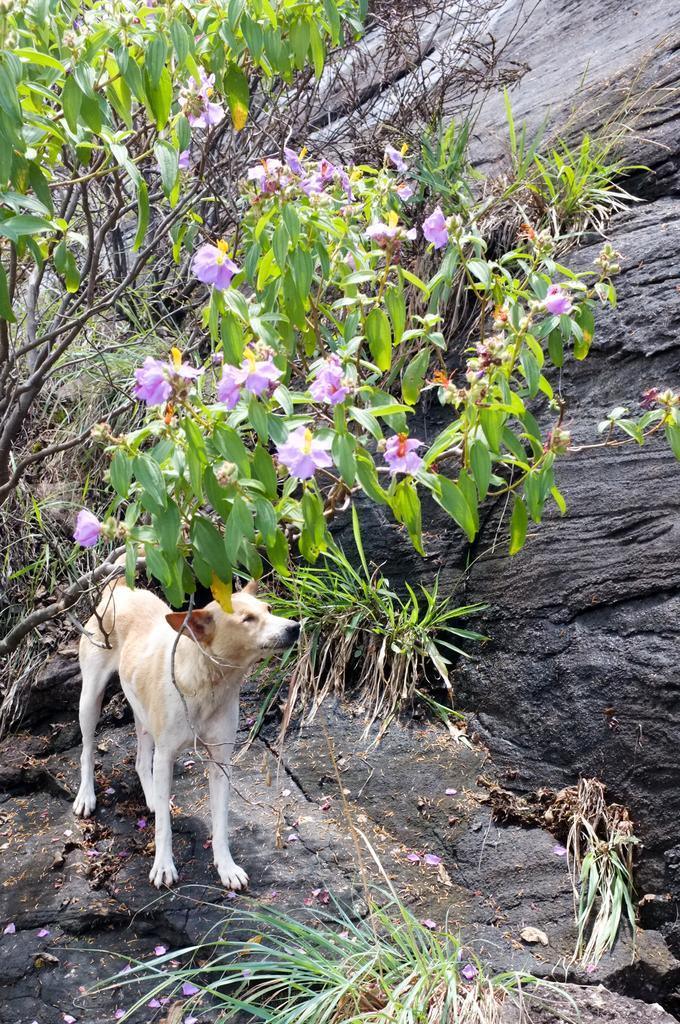Please provide a concise description of this image. In this image in the center there is a dog standing on the ground and there are trees in the background and there are rocks on the right side. 